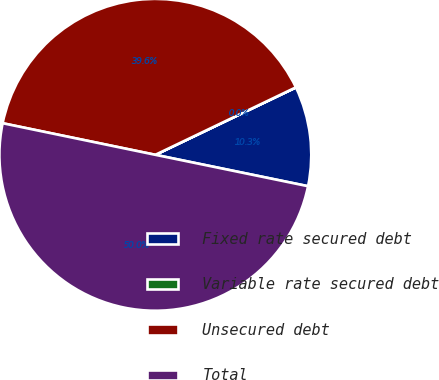Convert chart. <chart><loc_0><loc_0><loc_500><loc_500><pie_chart><fcel>Fixed rate secured debt<fcel>Variable rate secured debt<fcel>Unsecured debt<fcel>Total<nl><fcel>10.34%<fcel>0.01%<fcel>39.63%<fcel>50.02%<nl></chart> 